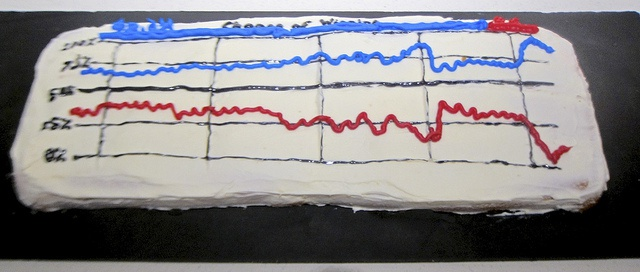Describe the objects in this image and their specific colors. I can see a cake in lightgray, darkgray, and gray tones in this image. 